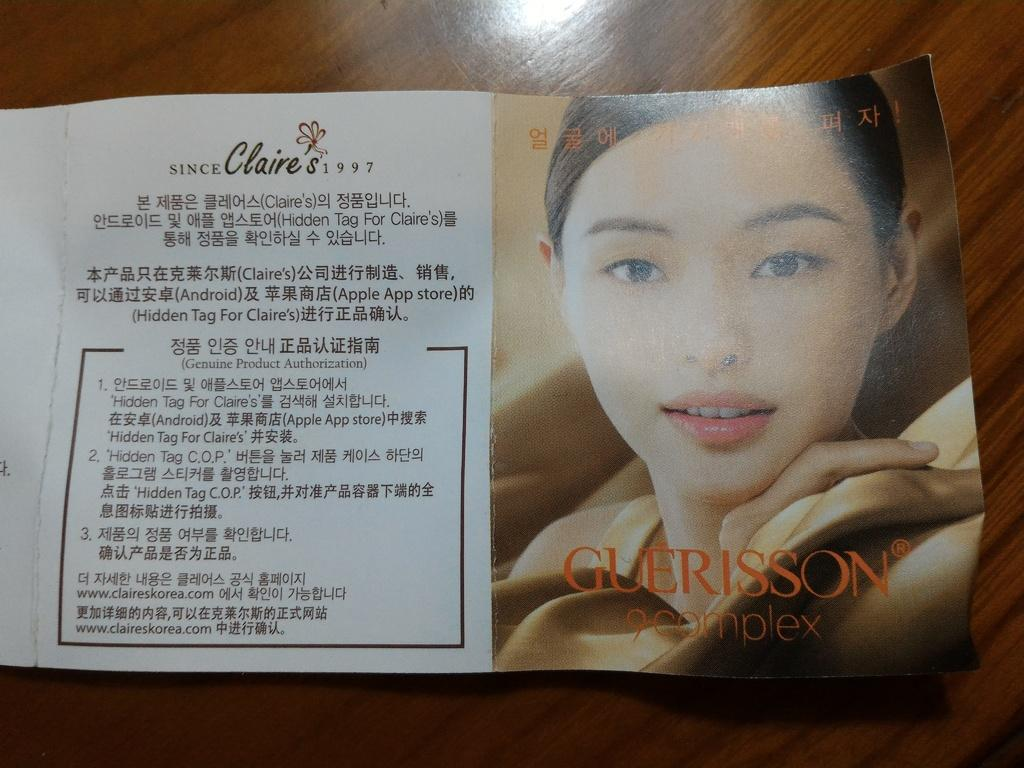What is the main object in the image? There is a truncated pamphlet in the image. Where is the pamphlet located? The pamphlet is on a surface. Can you describe the person in the image? There is a person in the image, but no specific details about their appearance or actions are provided. What can be found on the pamphlet? The pamphlet has text on it. What type of pear is being used as a pencil in the image? There is no pear or pencil present in the image. How many sodas are visible in the image? There is no soda present in the image. 